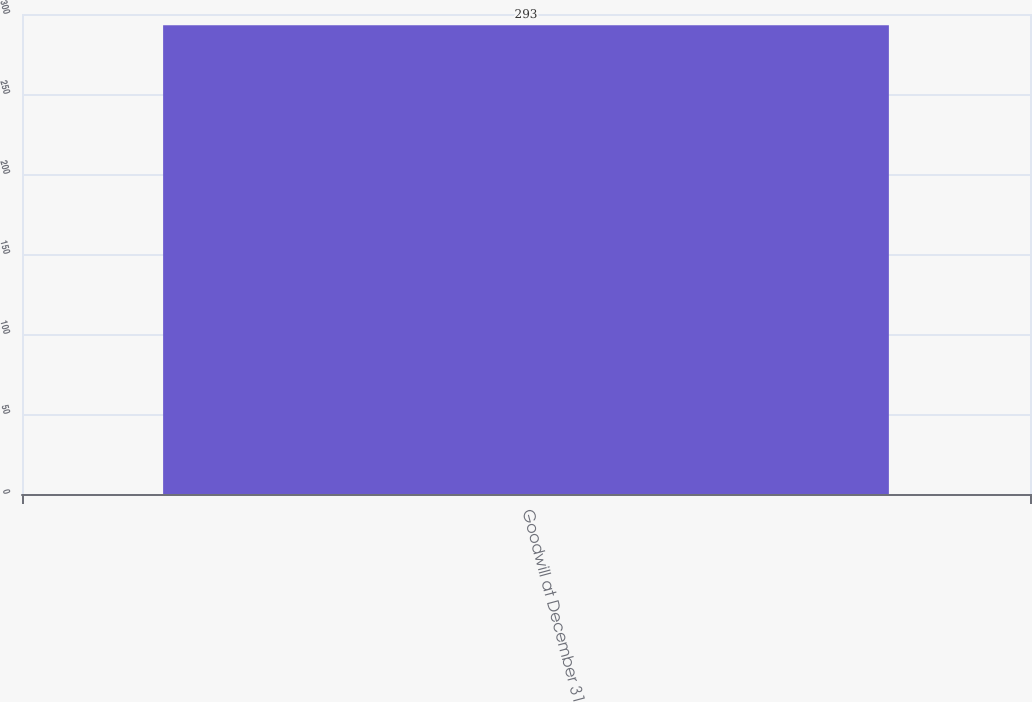Convert chart. <chart><loc_0><loc_0><loc_500><loc_500><bar_chart><fcel>Goodwill at December 31<nl><fcel>293<nl></chart> 